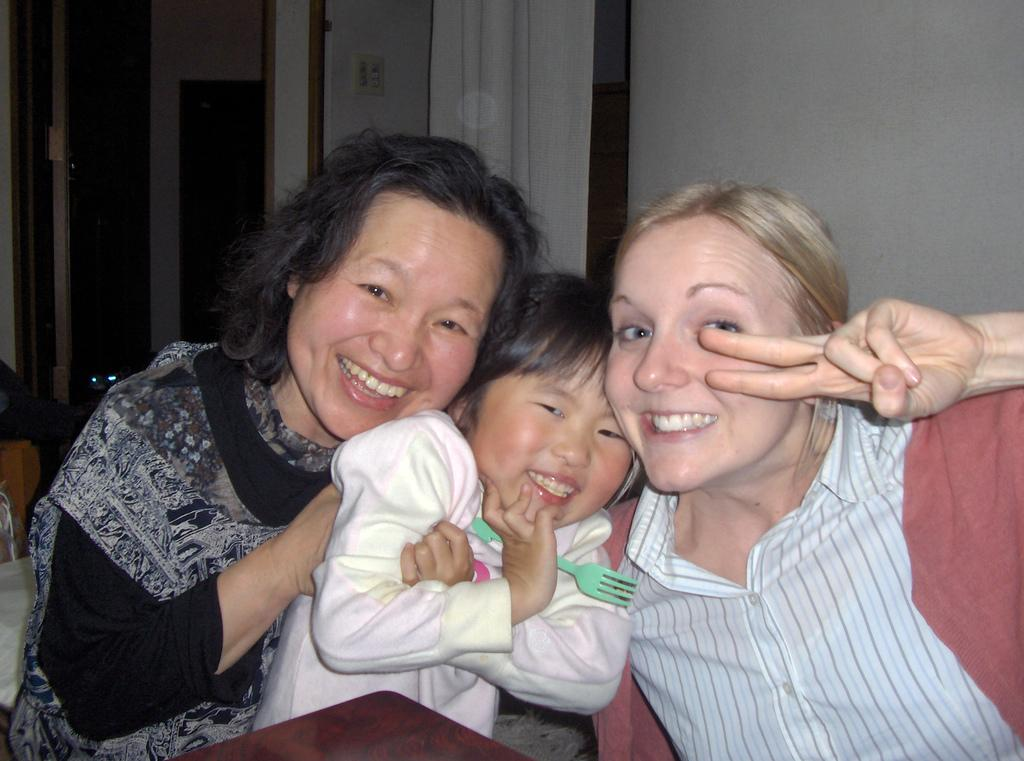How many people are in the image? There are two women and a kid in the image. What are the women and the kid doing in the image? They are sitting and smiling. What can be seen in the background of the image? There is a wall and a curtain in the background of the image. What type of goat can be seen jumping over the wall in the image? There is no goat present in the image, and therefore no such activity can be observed. 